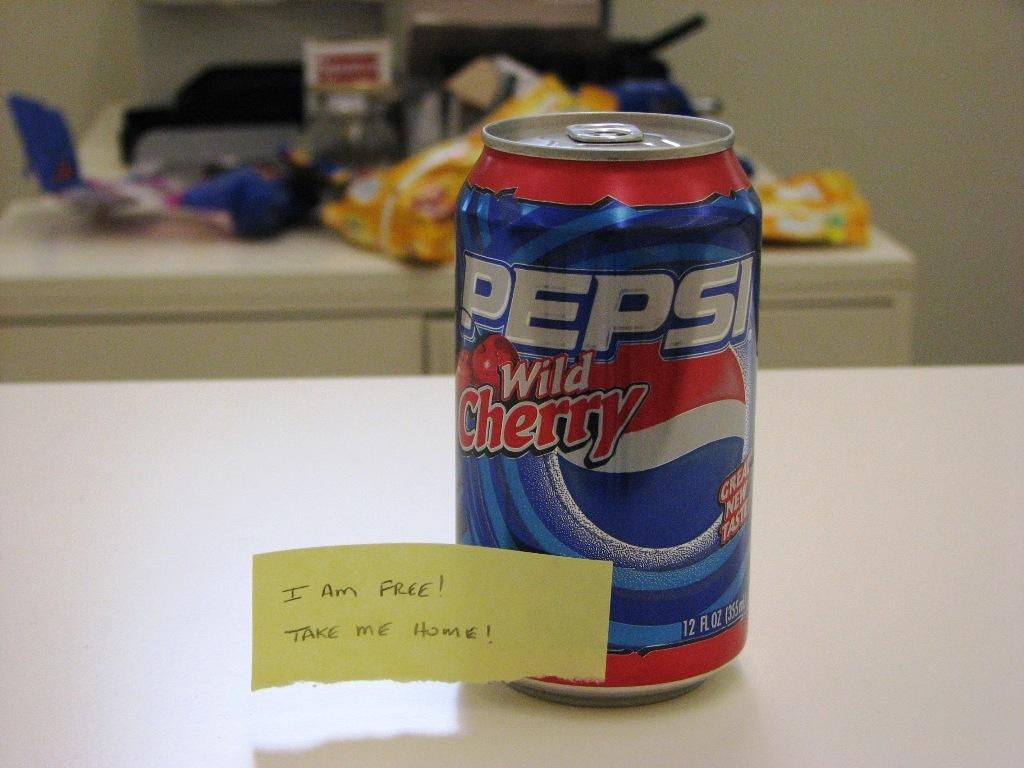Provide a one-sentence caption for the provided image. A can of wild cherry flavored Pepsi is on a counter. 